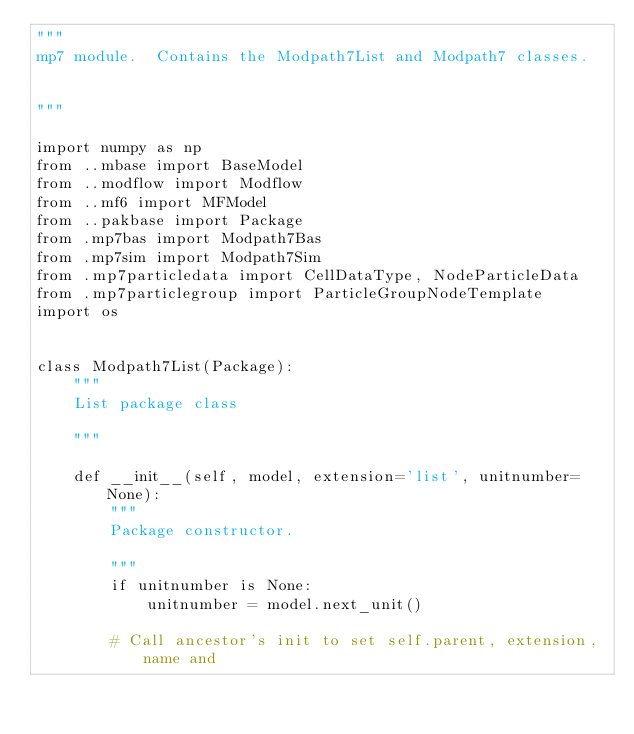<code> <loc_0><loc_0><loc_500><loc_500><_Python_>"""
mp7 module.  Contains the Modpath7List and Modpath7 classes.


"""

import numpy as np
from ..mbase import BaseModel
from ..modflow import Modflow
from ..mf6 import MFModel
from ..pakbase import Package
from .mp7bas import Modpath7Bas
from .mp7sim import Modpath7Sim
from .mp7particledata import CellDataType, NodeParticleData
from .mp7particlegroup import ParticleGroupNodeTemplate
import os


class Modpath7List(Package):
    """
    List package class

    """

    def __init__(self, model, extension='list', unitnumber=None):
        """
        Package constructor.

        """
        if unitnumber is None:
            unitnumber = model.next_unit()

        # Call ancestor's init to set self.parent, extension, name and</code> 